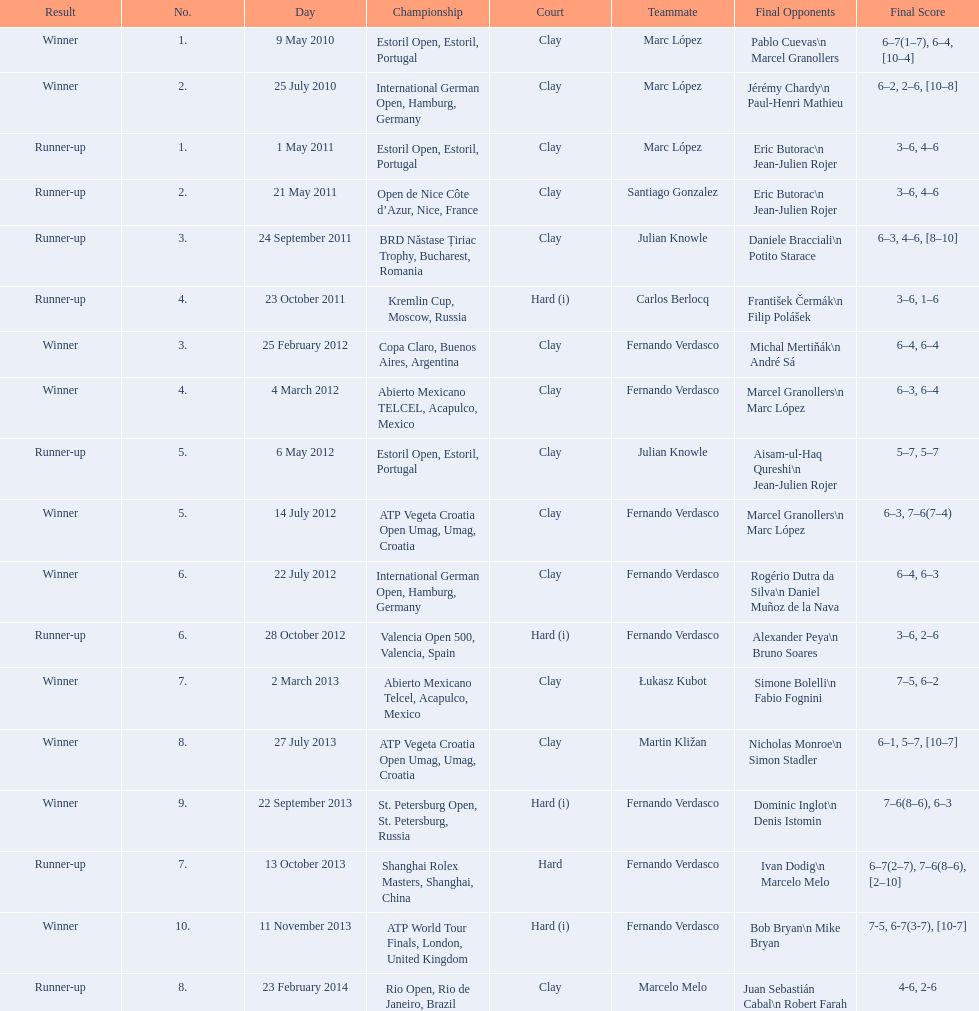Who won both the st.petersburg open and the atp world tour finals? Fernando Verdasco. 